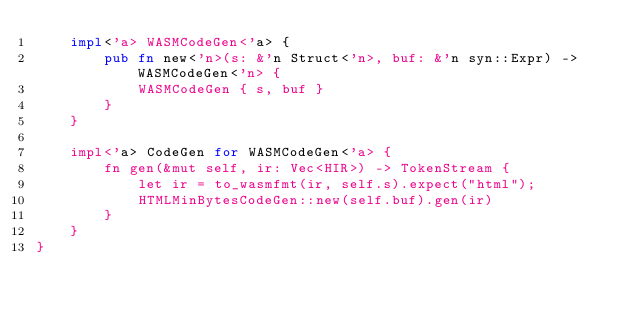<code> <loc_0><loc_0><loc_500><loc_500><_Rust_>    impl<'a> WASMCodeGen<'a> {
        pub fn new<'n>(s: &'n Struct<'n>, buf: &'n syn::Expr) -> WASMCodeGen<'n> {
            WASMCodeGen { s, buf }
        }
    }

    impl<'a> CodeGen for WASMCodeGen<'a> {
        fn gen(&mut self, ir: Vec<HIR>) -> TokenStream {
            let ir = to_wasmfmt(ir, self.s).expect("html");
            HTMLMinBytesCodeGen::new(self.buf).gen(ir)
        }
    }
}
</code> 